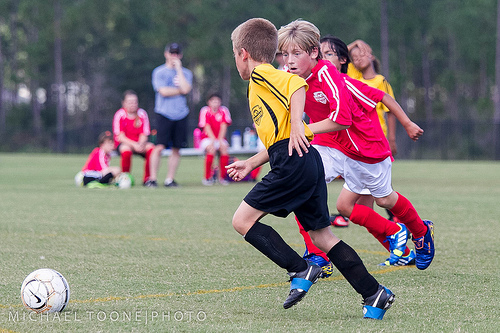<image>
Can you confirm if the player is behind the player? Yes. From this viewpoint, the player is positioned behind the player, with the player partially or fully occluding the player. Where is the boy in relation to the girl? Is it next to the girl? No. The boy is not positioned next to the girl. They are located in different areas of the scene. 